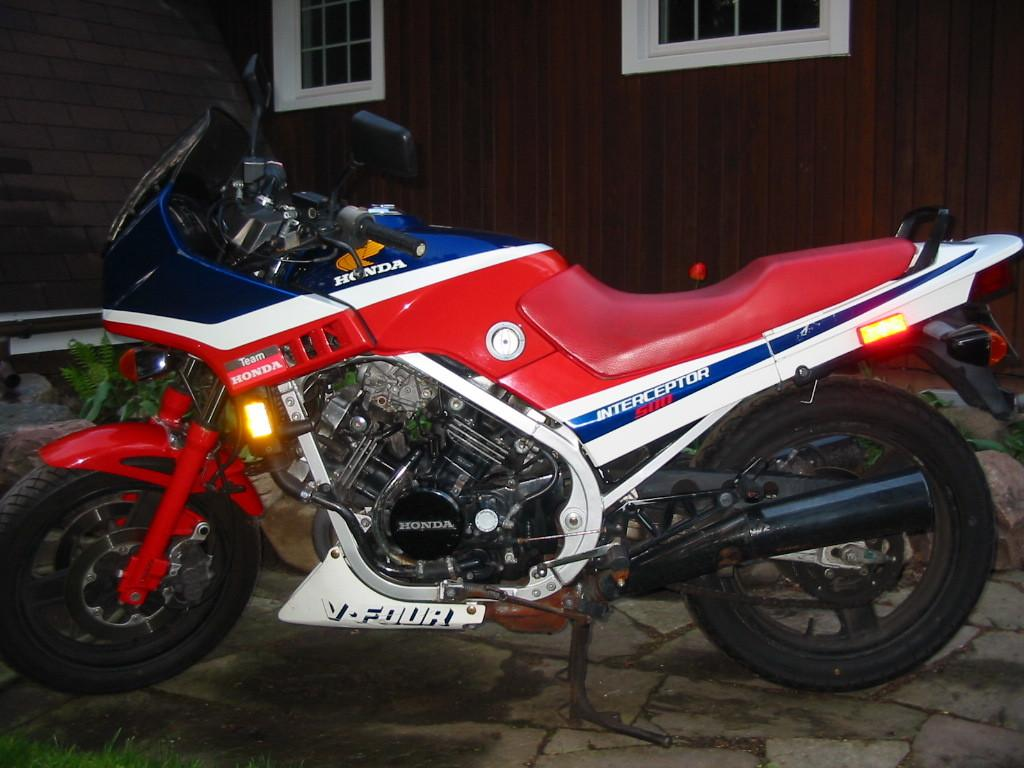What is the main subject of the image? The main subject of the image is a motorbike. What can be seen behind the motorbike? There is a plant and rocks behind the motorbike. What architectural features are visible in the background of the image? There are windows and a wall in the background of the image. How many babies are playing with bears in the image? There are no babies or bears present in the image; it features a motorbike with a plant and rocks behind it. 